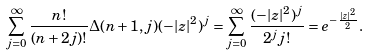<formula> <loc_0><loc_0><loc_500><loc_500>\sum _ { j = 0 } ^ { \infty } \frac { n ! } { ( n + 2 j ) ! } \Delta ( n + 1 , j ) ( - | z | ^ { 2 } ) ^ { j } = \sum _ { j = 0 } ^ { \infty } \frac { ( - | z | ^ { 2 } ) ^ { j } } { 2 ^ { j } j ! } = e ^ { - \frac { | z | ^ { 2 } } { 2 } } .</formula> 